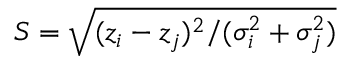<formula> <loc_0><loc_0><loc_500><loc_500>S = \sqrt { ( z _ { i } - z _ { j } ) ^ { 2 } / ( \sigma _ { i } ^ { 2 } + \sigma _ { j } ^ { 2 } ) }</formula> 